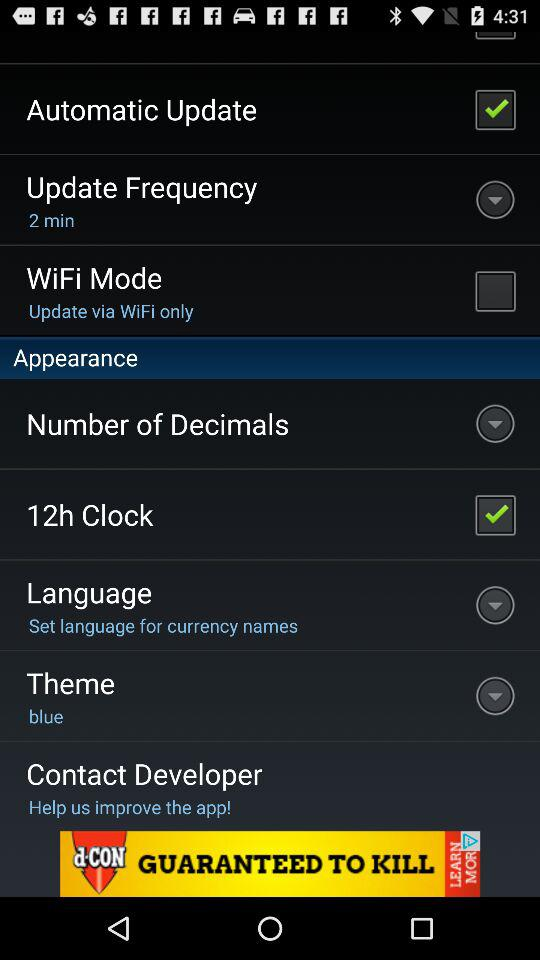Which theme is selected? The selected theme is "blue". 